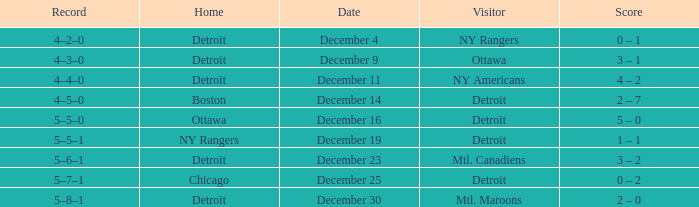What score has detroit as the home, and December 9 as the date? 3 – 1. Would you mind parsing the complete table? {'header': ['Record', 'Home', 'Date', 'Visitor', 'Score'], 'rows': [['4–2–0', 'Detroit', 'December 4', 'NY Rangers', '0 – 1'], ['4–3–0', 'Detroit', 'December 9', 'Ottawa', '3 – 1'], ['4–4–0', 'Detroit', 'December 11', 'NY Americans', '4 – 2'], ['4–5–0', 'Boston', 'December 14', 'Detroit', '2 – 7'], ['5–5–0', 'Ottawa', 'December 16', 'Detroit', '5 – 0'], ['5–5–1', 'NY Rangers', 'December 19', 'Detroit', '1 – 1'], ['5–6–1', 'Detroit', 'December 23', 'Mtl. Canadiens', '3 – 2'], ['5–7–1', 'Chicago', 'December 25', 'Detroit', '0 – 2'], ['5–8–1', 'Detroit', 'December 30', 'Mtl. Maroons', '2 – 0']]} 